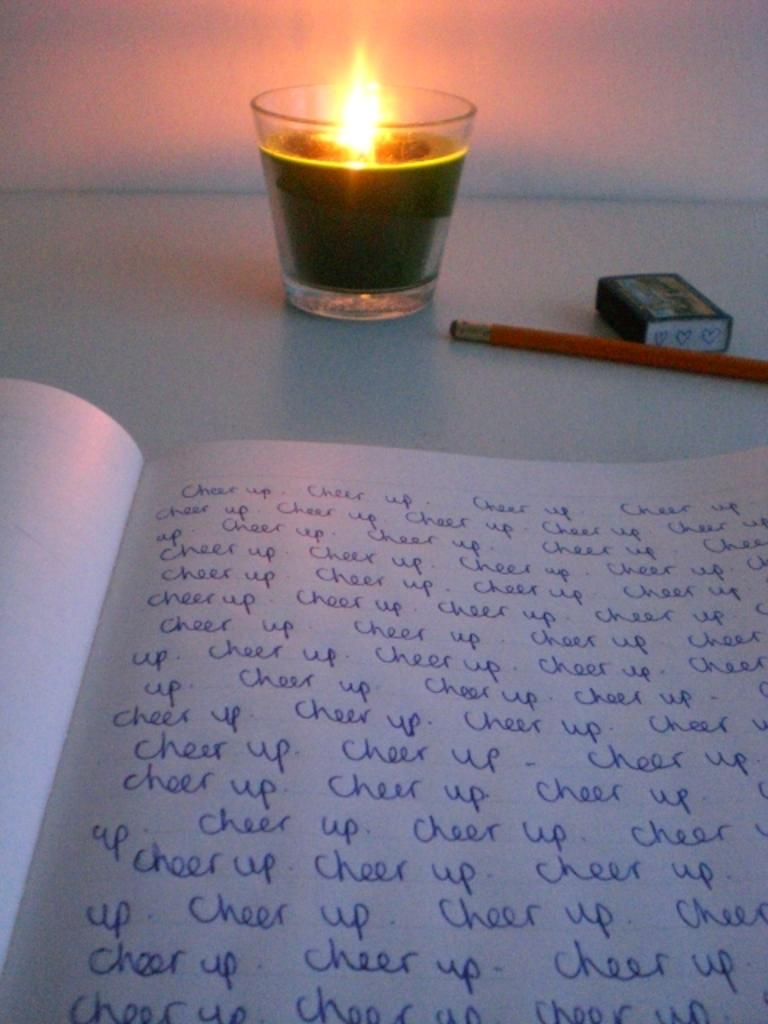What object is located at the bottom of the image? There is a book at the bottom of the image. What can be seen in the background of the image? There is a candle in the background of the image. What writing instrument is present in the image? There is a pencil in the image. What is used for correcting mistakes in the image? There is an eraser in the image. What type of structure is visible in the image? There is a wall in the image. What type of dinosaur can be seen playing a game in the image? There are no dinosaurs or games present in the image. What type of root is visible in the image? There is no root visible in the image. 